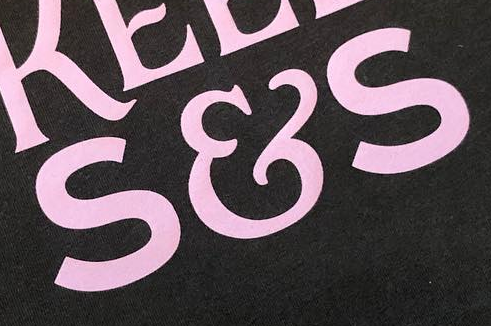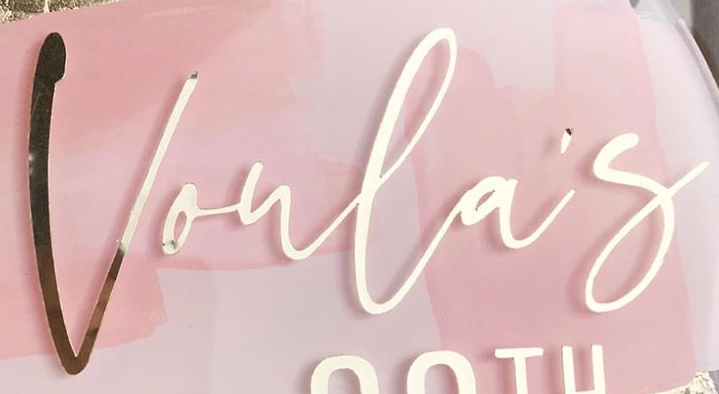Transcribe the words shown in these images in order, separated by a semicolon. S&S; Voula's 